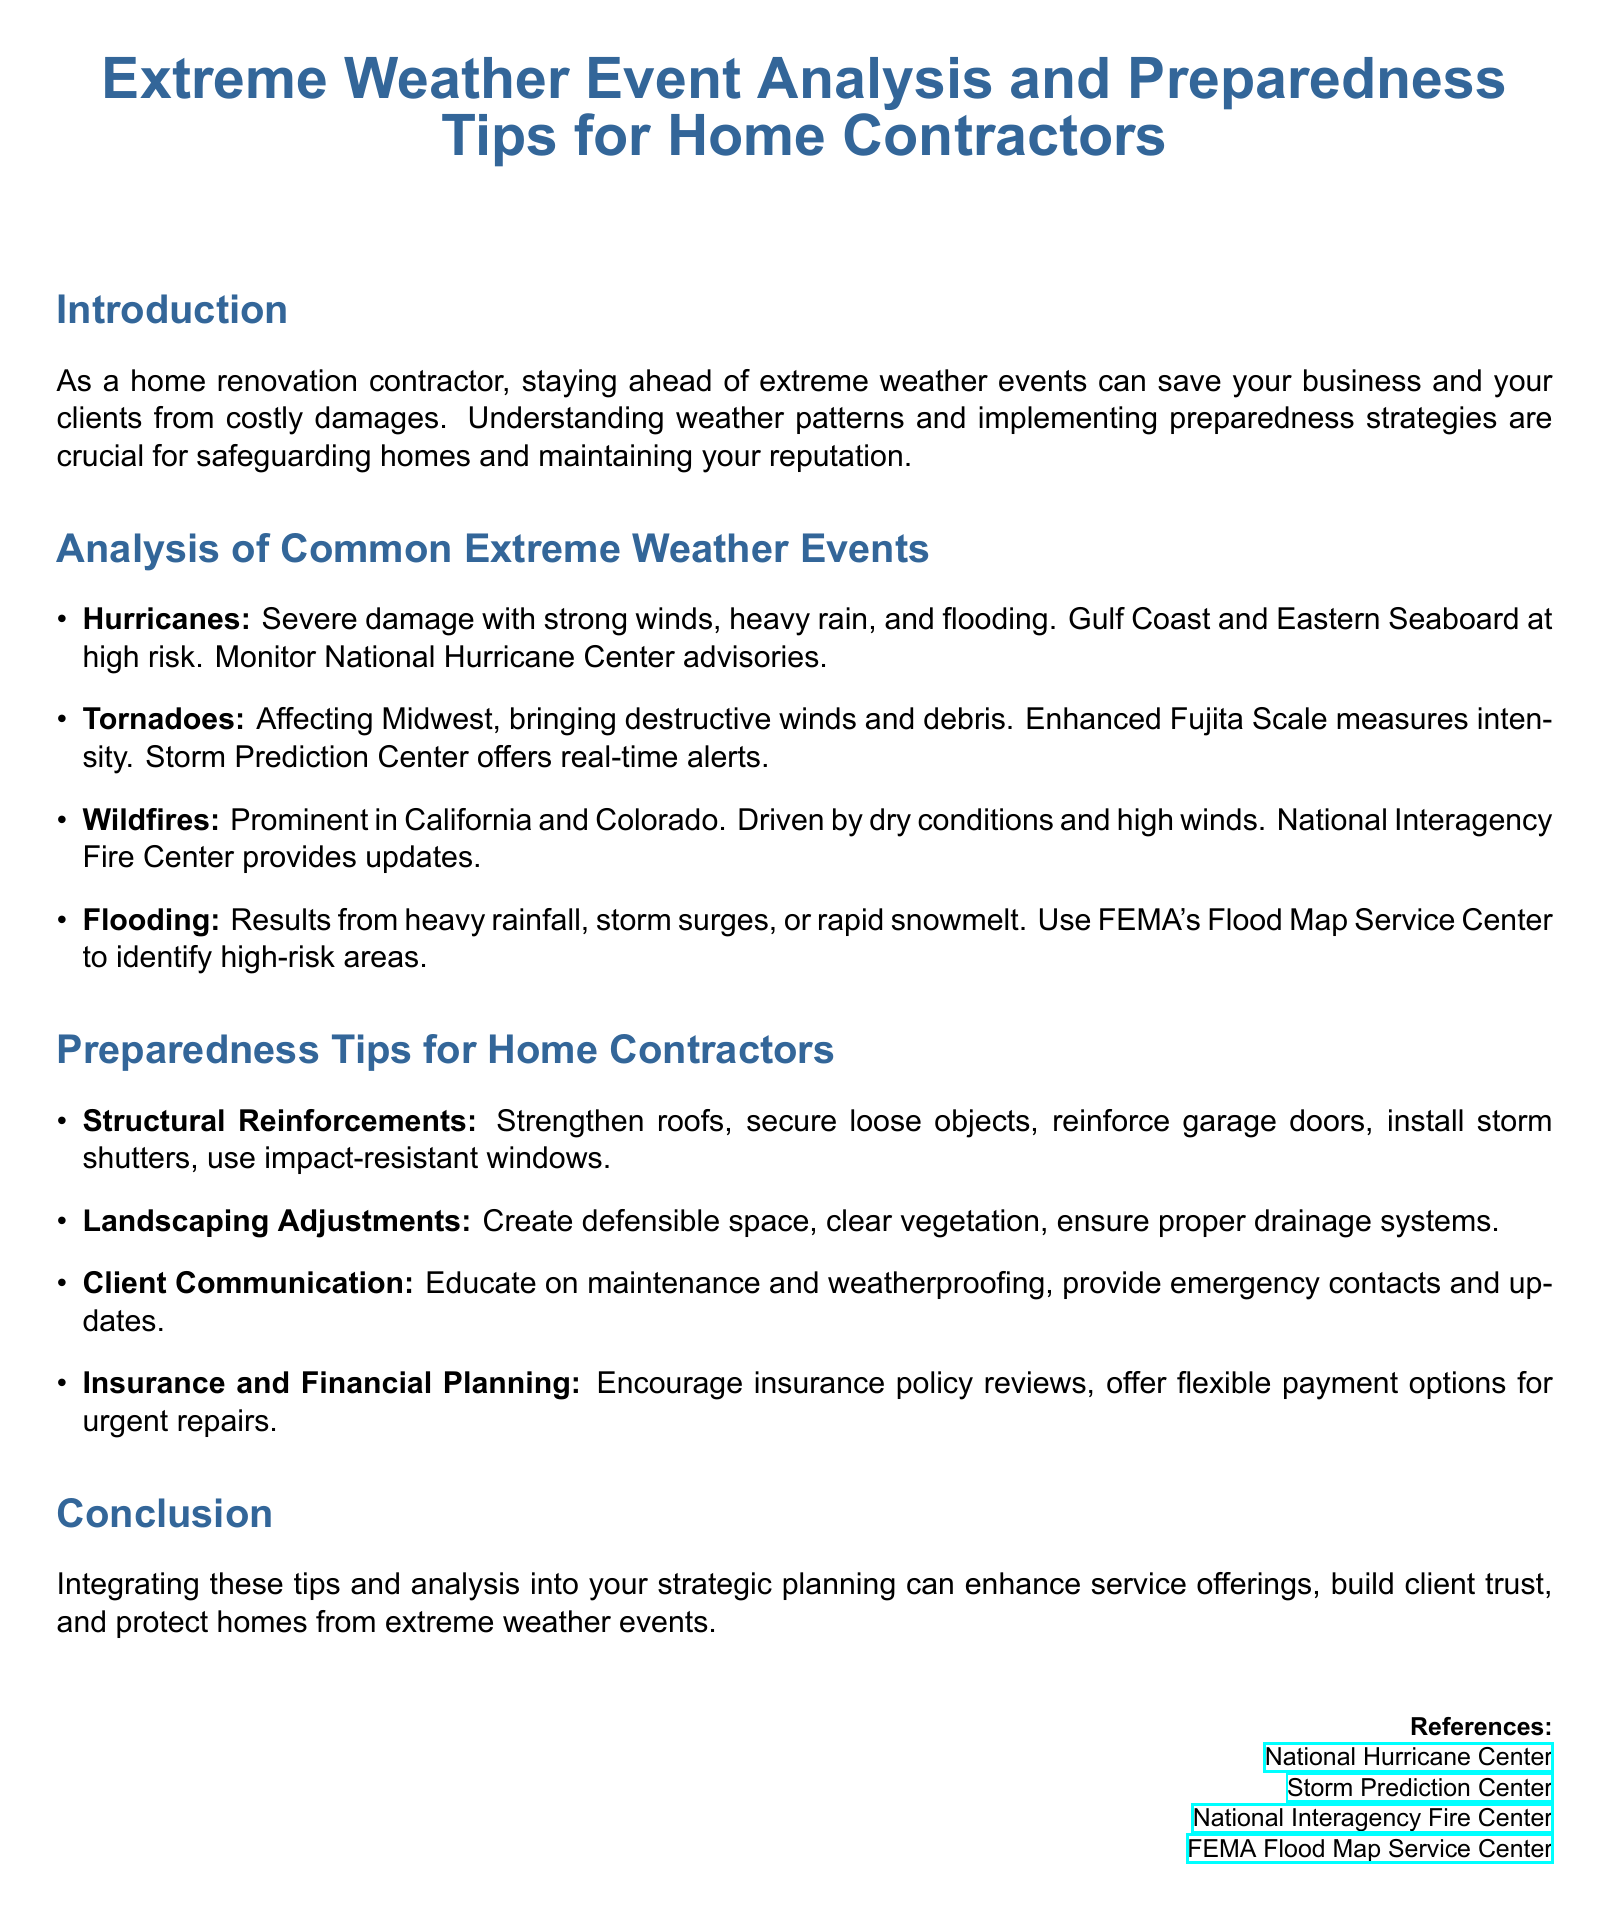What are the primary weather events analyzed? The document lists four common extreme weather events analyzed: Hurricanes, Tornadoes, Wildfires, and Flooding.
Answer: Hurricanes, Tornadoes, Wildfires, Flooding What scale is used to measure tornado intensity? The document mentions the Enhanced Fujita Scale for measuring tornado intensity.
Answer: Enhanced Fujita Scale Which organization provides flood risk maps? The document specifies that FEMA's Flood Map Service Center is used to identify high-risk areas for flooding.
Answer: FEMA Flood Map Service Center What is a recommended structural reinforcement? A specific recommendation for structural reinforcement mentioned is to secure loose objects.
Answer: Secure loose objects Where are hurricanes primarily a risk? The document states that the Gulf Coast and Eastern Seaboard are at high risk for hurricanes.
Answer: Gulf Coast and Eastern Seaboard How can contractors assist clients during extreme weather events? The document advises contractors to educate clients on maintenance and weatherproofing as part of their preparedness strategy.
Answer: Educate on maintenance and weatherproofing What is recommended for landscaping adjustments? The document suggests creating defensible space as part of landscaping adjustments.
Answer: Create defensible space What does the document state about insurance planning? The document highlights the importance of encouraging insurance policy reviews.
Answer: Encourage insurance policy reviews Which organization provides real-time tornado alerts? The Storm Prediction Center is mentioned as the organization that offers real-time alerts for tornadoes.
Answer: Storm Prediction Center 